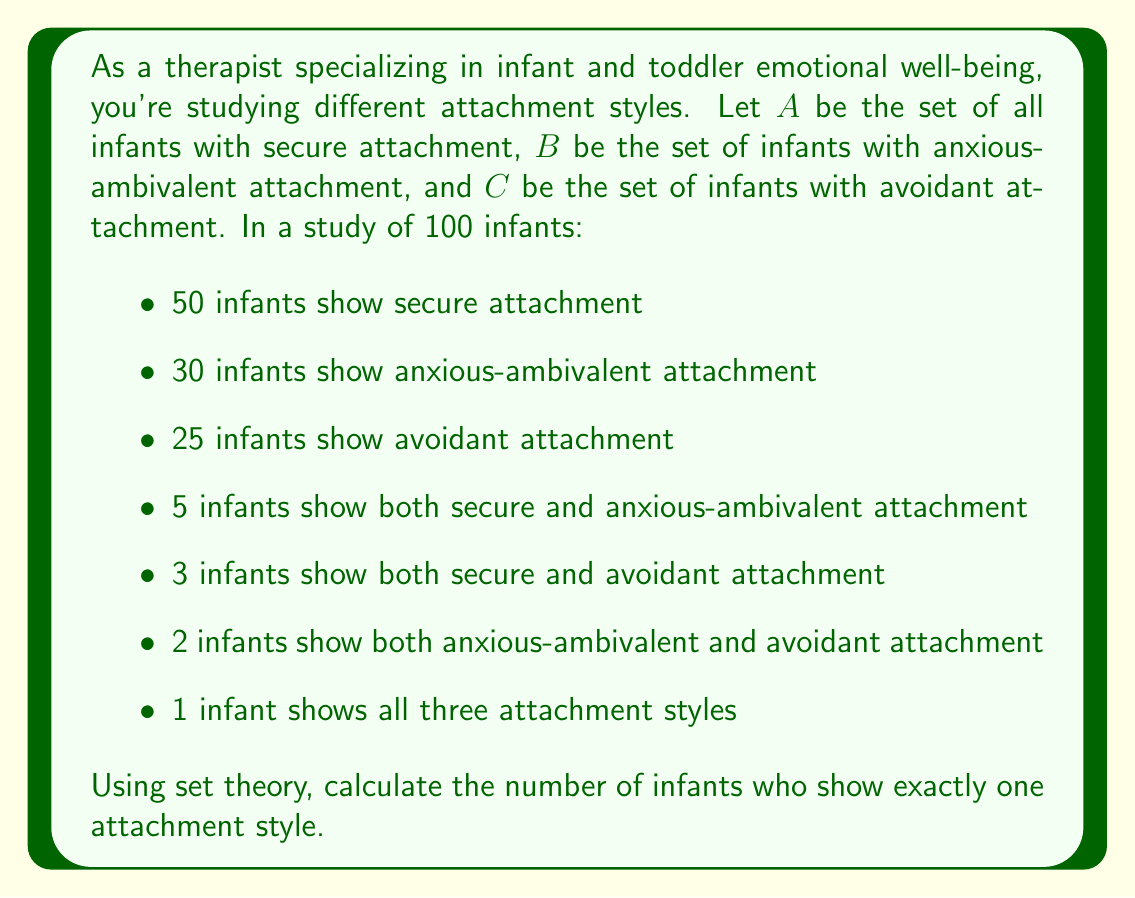Help me with this question. To solve this problem, we'll use the principle of inclusion-exclusion from set theory. Let's break it down step-by-step:

1) First, let's define our universe $U$ as all 100 infants in the study.

2) We're given:
   $|A| = 50$, $|B| = 30$, $|C| = 25$
   $|A \cap B| = 5$, $|A \cap C| = 3$, $|B \cap C| = 2$
   $|A \cap B \cap C| = 1$

3) The total number of infants with at least one attachment style is:
   $|A \cup B \cup C| = |A| + |B| + |C| - |A \cap B| - |A \cap C| - |B \cap C| + |A \cap B \cap C|$

4) Substituting the values:
   $|A \cup B \cup C| = 50 + 30 + 25 - 5 - 3 - 2 + 1 = 96$

5) This means 96 infants show at least one attachment style.

6) To find those with exactly one attachment style, we need to subtract those with two or more styles:
   - Infants with exactly two styles: $(5-1) + (3-1) + (2-1) = 4 + 2 + 1 = 7$
   - Infants with all three styles: 1

7) Therefore, the number of infants with exactly one attachment style is:
   $96 - 7 - 1 = 88$
Answer: 88 infants show exactly one attachment style. 